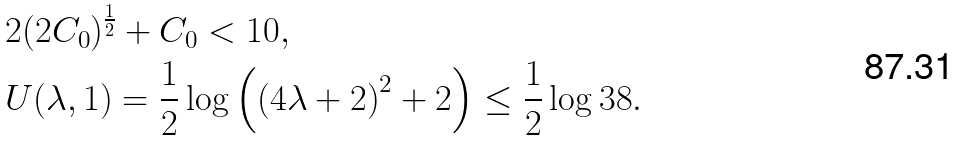<formula> <loc_0><loc_0><loc_500><loc_500>& 2 ( 2 C _ { 0 } ) ^ { \frac { 1 } { 2 } } + C _ { 0 } < 1 0 , \\ & U ( \lambda , 1 ) = \frac { 1 } { 2 } \log { \left ( \left ( 4 \lambda + 2 \right ) ^ { 2 } + 2 \right ) } \leq \frac { 1 } { 2 } \log { 3 8 } .</formula> 